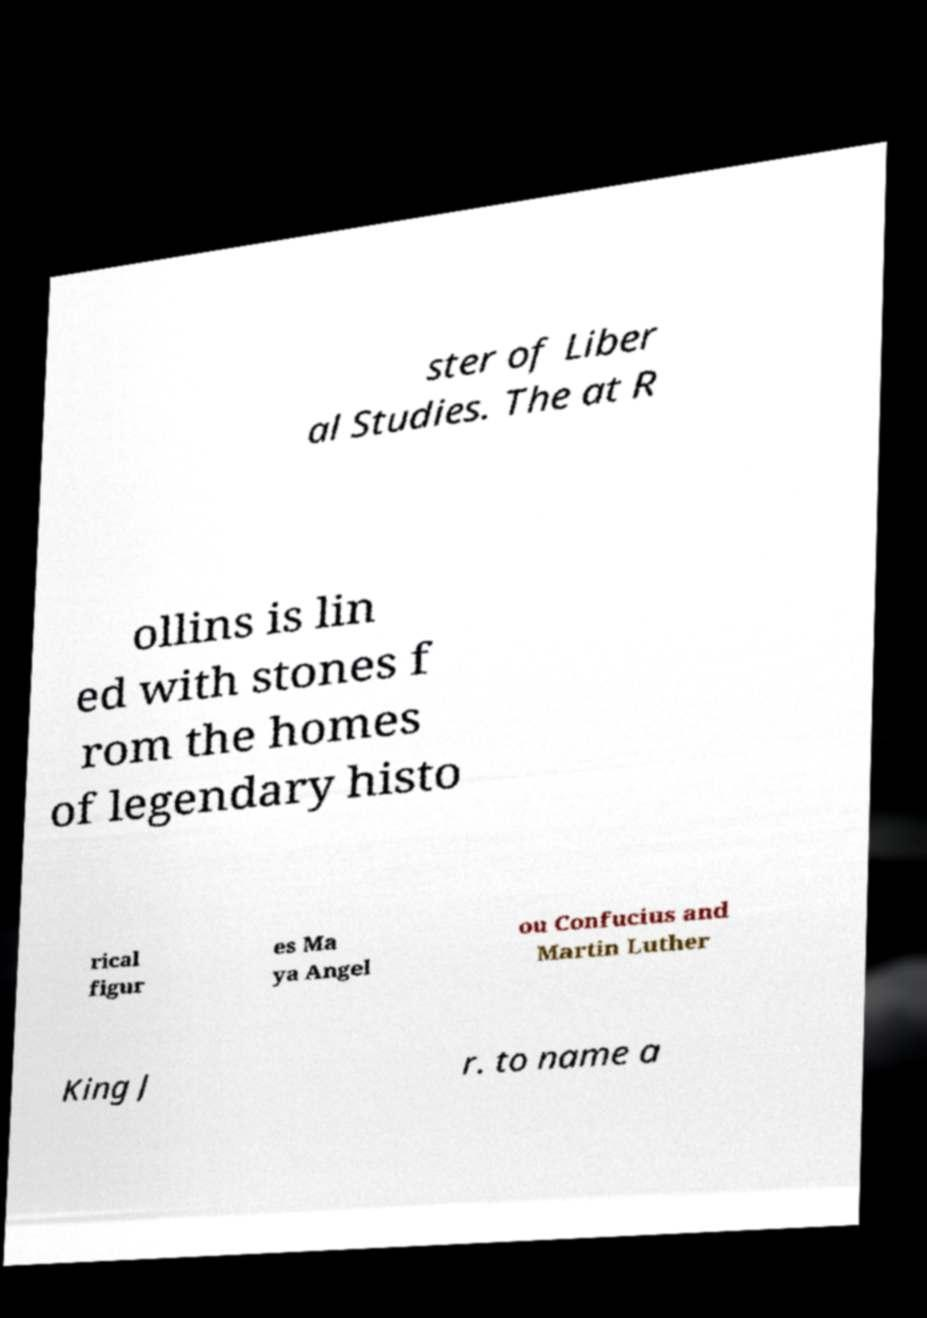Please read and relay the text visible in this image. What does it say? ster of Liber al Studies. The at R ollins is lin ed with stones f rom the homes of legendary histo rical figur es Ma ya Angel ou Confucius and Martin Luther King J r. to name a 